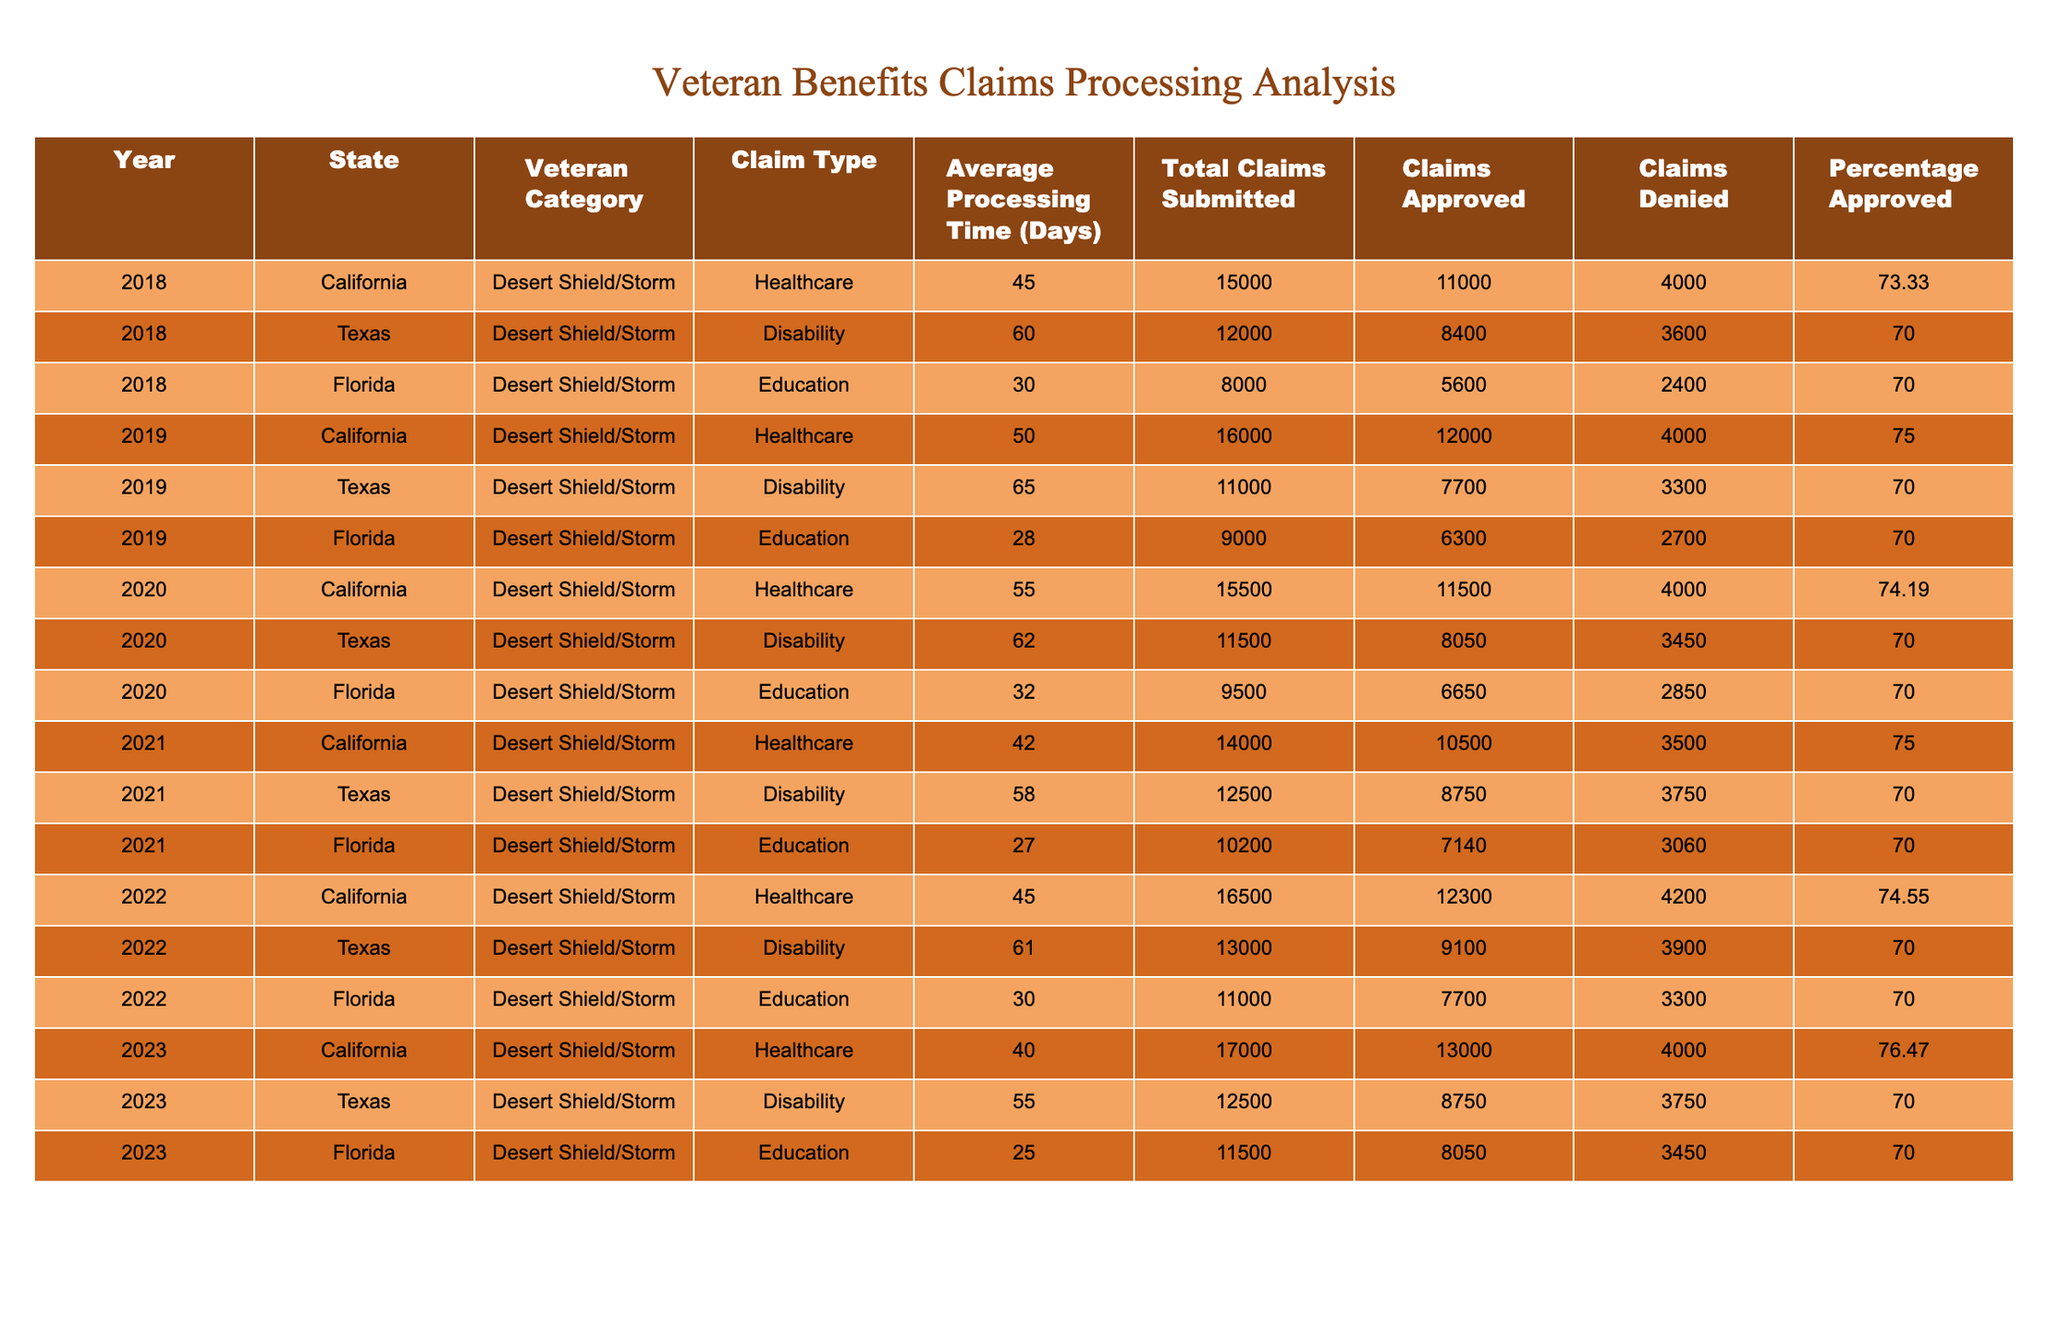What was the average processing time for healthcare claims in California from 2018 to 2023? The average processing times for healthcare claims in California are: 2018 (45 days), 2019 (50 days), 2020 (55 days), 2021 (42 days), 2022 (45 days), and 2023 (40 days). We sum these values: 45 + 50 + 55 + 42 + 45 + 40 = 277 days. We then divide by the number of years (6) to get the average: 277 / 6 = 46.17 days.
Answer: 46.17 days Which state had the highest percentage of approved claims for disability in 2021? The percentage of approved claims for disability in 2021 for each state is: California (70%), Texas (70%), and Florida (70%). Since all states have the same percentage, no state is higher than the others.
Answer: None How many total claims were submitted for education in Florida across all years? The total claims submitted for education in Florida are: 2018 (8000), 2019 (9000), 2020 (9500), 2021 (10200), 2022 (11000), and 2023 (11500). We sum these values: 8000 + 9000 + 9500 + 10200 + 11000 + 11500 = 60000 total claims.
Answer: 60000 What is the difference in average processing times for healthcare claims in California from 2018 to 2023? The average processing times for healthcare claims in California are: 2018 (45 days) and 2023 (40 days). The difference is calculated as 45 - 40 = 5 days.
Answer: 5 days Did any state show a decrease in processing times for healthcare claims from 2021 to 2022? For California, the processing time decreased from 42 days in 2021 to 45 days in 2022, showing an increase. Texas remained at 62 days, and Florida went from 27 days in 2021 to 30 days in 2022, which is also an increase. Hence, no state showed a decrease.
Answer: No Which year had the highest number of total claims submitted across all states for education? The total claims for education per year are as follows: 2018 (8000), 2019 (9000), 2020 (9500), 2021 (10200), 2022 (11000), and 2023 (11500). The highest number of total claims is in 2023 with 11500 claims.
Answer: 2023 What was the average percentage of approved claims for disability across all years and states? The percentage of claims approved for disability across years and states is: 70% for Texas in 2018, 70% for Texas in 2019, 70% for Texas in 2020, 70% for Texas in 2021, 70% for Texas in 2022, and 70% for Texas in 2023. Since all percentages are the same, the average is 70%.
Answer: 70% How many claims were denied for education in Florida in 2021? In 2021, the number of claims denied for education in Florida is 3060, as shown in that year's data entry for Florida's education claims.
Answer: 3060 Which claim type had the fastest average processing time in 2020 for California? The average processing times for claim types in California for 2020 are: Healthcare (55 days). Out of the available claim types, healthcare had the fastest processing time with 55 days.
Answer: Healthcare What is the trend in average processing times for education claims in Florida over the years? The processing times for education claims in Florida are: 2018 (30 days), 2019 (28 days), 2020 (32 days), 2021 (27 days), 2022 (30 days), and 2023 (25 days). Overall, the trend shows a decline, ultimately reaching 25 days in 2023.
Answer: Declining trend 